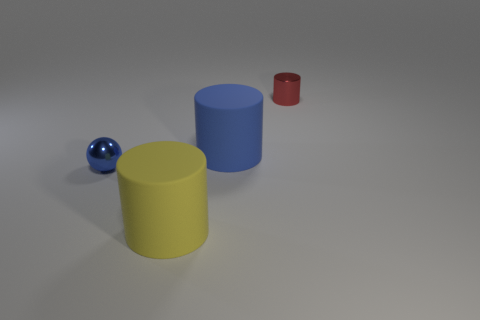How many shiny objects have the same size as the metal ball? There is one shiny object that appears to be the same size as the metal ball, which is the small red cylinder. 